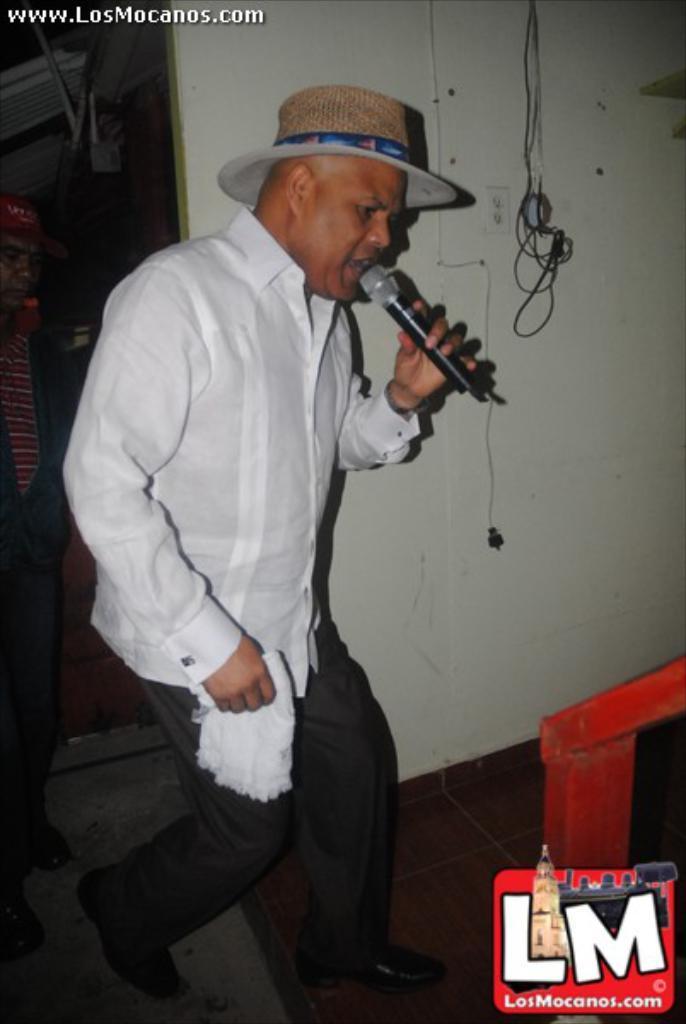In one or two sentences, can you explain what this image depicts? On the background we can see a wall and wires. Here we can see a man wearing white colour shirt and a hat and he is holding a mike in his hand and singing. 